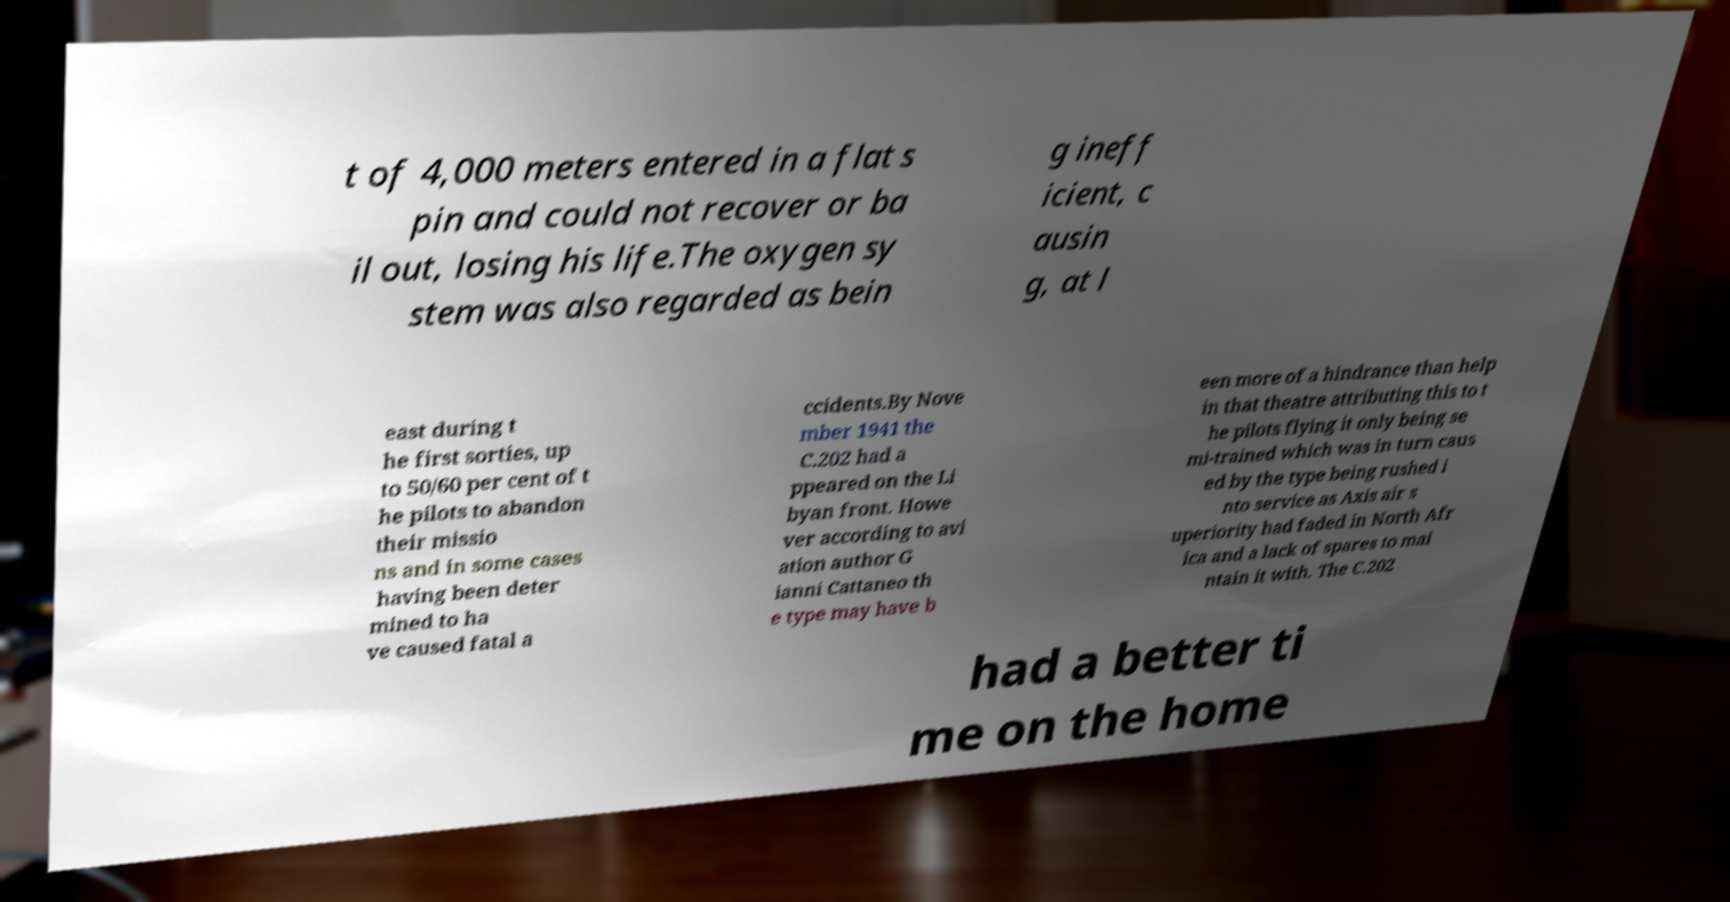Could you extract and type out the text from this image? t of 4,000 meters entered in a flat s pin and could not recover or ba il out, losing his life.The oxygen sy stem was also regarded as bein g ineff icient, c ausin g, at l east during t he first sorties, up to 50/60 per cent of t he pilots to abandon their missio ns and in some cases having been deter mined to ha ve caused fatal a ccidents.By Nove mber 1941 the C.202 had a ppeared on the Li byan front. Howe ver according to avi ation author G ianni Cattaneo th e type may have b een more of a hindrance than help in that theatre attributing this to t he pilots flying it only being se mi-trained which was in turn caus ed by the type being rushed i nto service as Axis air s uperiority had faded in North Afr ica and a lack of spares to mai ntain it with. The C.202 had a better ti me on the home 